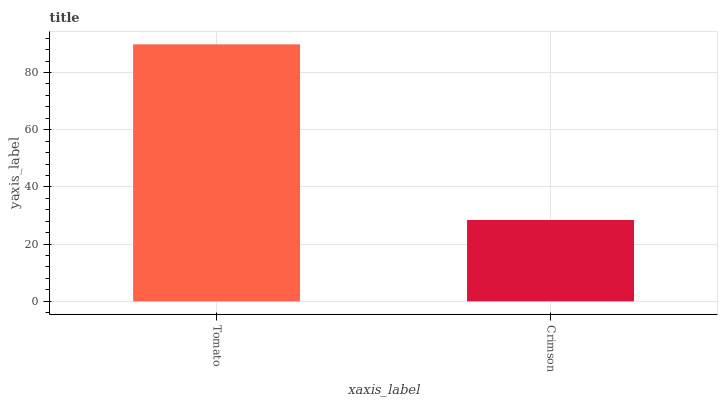Is Crimson the minimum?
Answer yes or no. Yes. Is Tomato the maximum?
Answer yes or no. Yes. Is Crimson the maximum?
Answer yes or no. No. Is Tomato greater than Crimson?
Answer yes or no. Yes. Is Crimson less than Tomato?
Answer yes or no. Yes. Is Crimson greater than Tomato?
Answer yes or no. No. Is Tomato less than Crimson?
Answer yes or no. No. Is Tomato the high median?
Answer yes or no. Yes. Is Crimson the low median?
Answer yes or no. Yes. Is Crimson the high median?
Answer yes or no. No. Is Tomato the low median?
Answer yes or no. No. 